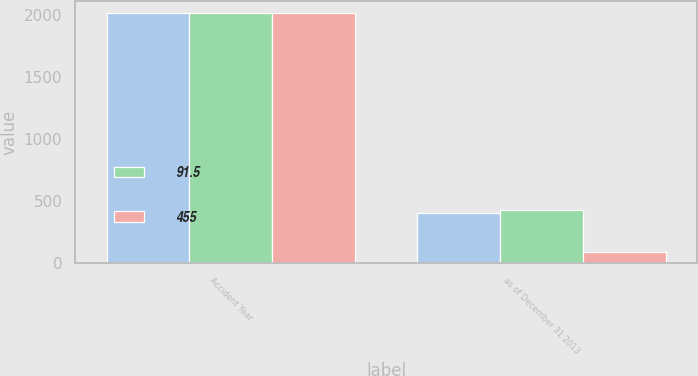Convert chart. <chart><loc_0><loc_0><loc_500><loc_500><stacked_bar_chart><ecel><fcel>Accident Year<fcel>as of December 31 2013<nl><fcel>nan<fcel>2013<fcel>408<nl><fcel>91.5<fcel>2011<fcel>432<nl><fcel>455<fcel>2011<fcel>86.9<nl></chart> 